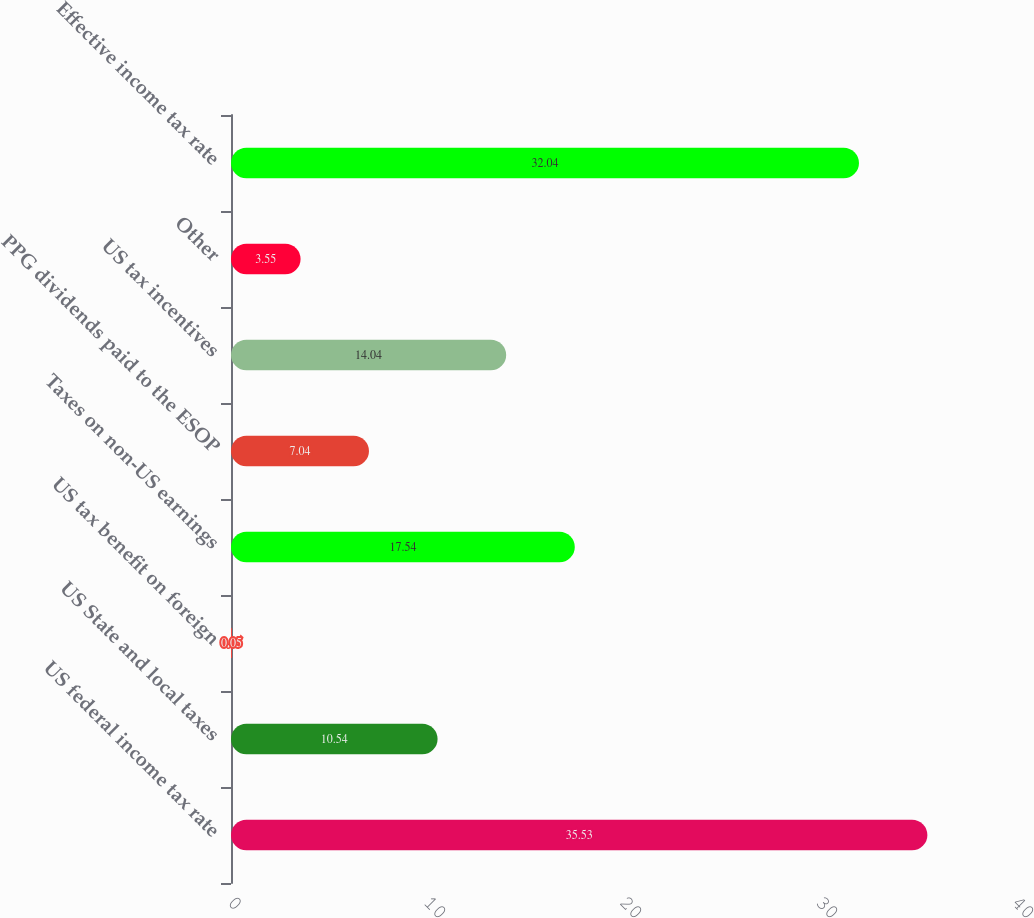Convert chart to OTSL. <chart><loc_0><loc_0><loc_500><loc_500><bar_chart><fcel>US federal income tax rate<fcel>US State and local taxes<fcel>US tax benefit on foreign<fcel>Taxes on non-US earnings<fcel>PPG dividends paid to the ESOP<fcel>US tax incentives<fcel>Other<fcel>Effective income tax rate<nl><fcel>35.53<fcel>10.54<fcel>0.05<fcel>17.54<fcel>7.04<fcel>14.04<fcel>3.55<fcel>32.04<nl></chart> 